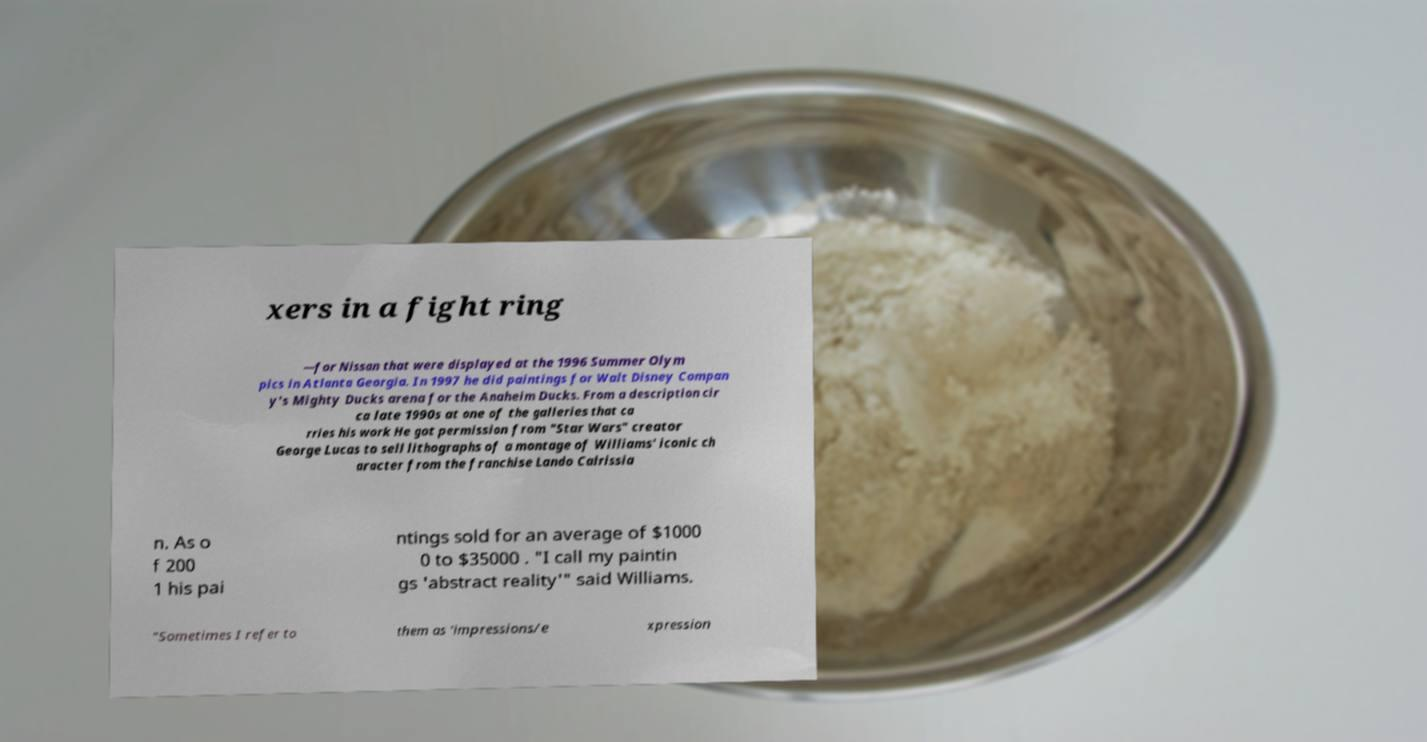Could you assist in decoding the text presented in this image and type it out clearly? xers in a fight ring —for Nissan that were displayed at the 1996 Summer Olym pics in Atlanta Georgia. In 1997 he did paintings for Walt Disney Compan y's Mighty Ducks arena for the Anaheim Ducks. From a description cir ca late 1990s at one of the galleries that ca rries his work He got permission from "Star Wars" creator George Lucas to sell lithographs of a montage of Williams' iconic ch aracter from the franchise Lando Calrissia n. As o f 200 1 his pai ntings sold for an average of $1000 0 to $35000 . "I call my paintin gs 'abstract reality'" said Williams. "Sometimes I refer to them as 'impressions/e xpression 